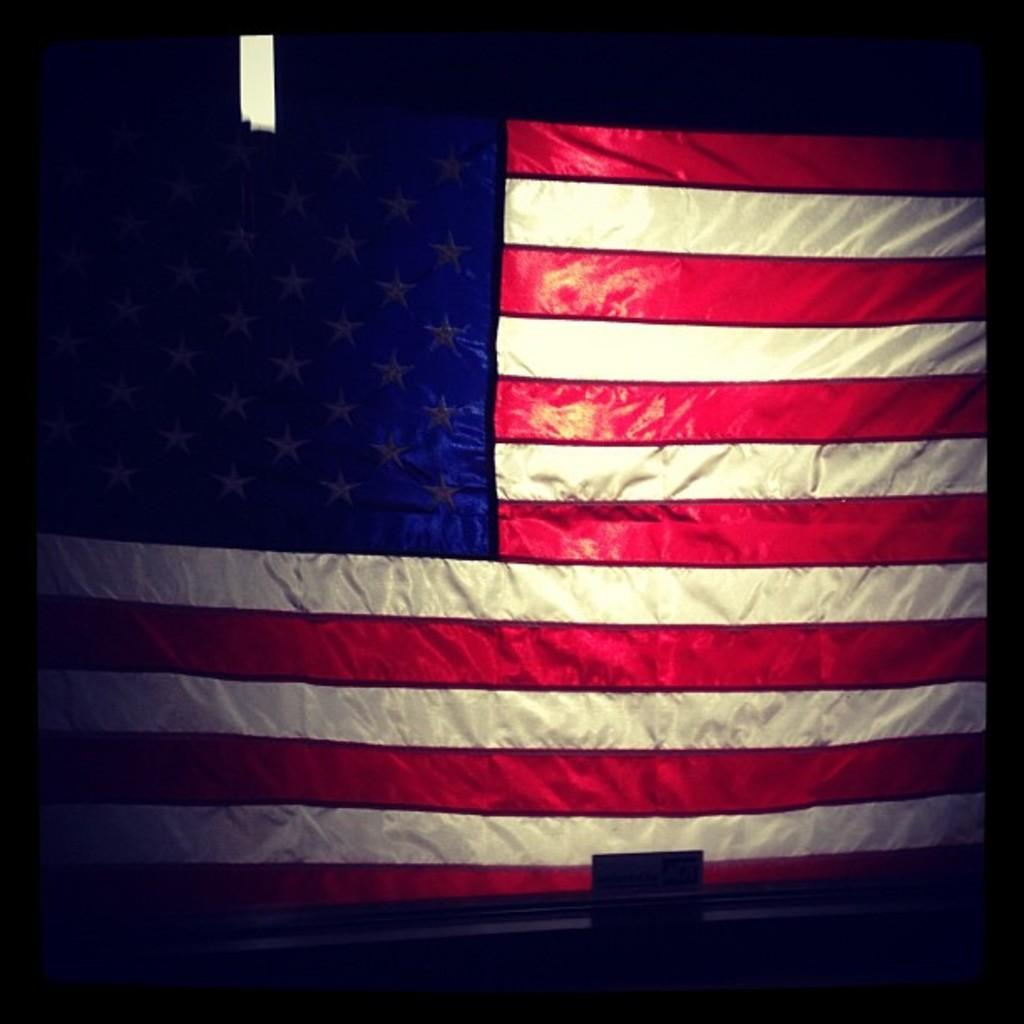What flag is visible in the image? There is a flag of the USA in the image. Can you describe the lighting conditions in the image? The image is a little bit dark. What type of engine is being offered in the image? There is no engine present in the image, and no offer is being made. 